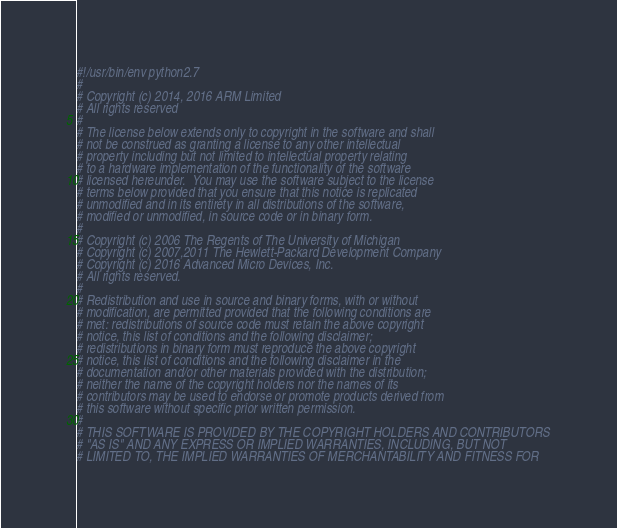Convert code to text. <code><loc_0><loc_0><loc_500><loc_500><_Python_>#!/usr/bin/env python2.7
#
# Copyright (c) 2014, 2016 ARM Limited
# All rights reserved
#
# The license below extends only to copyright in the software and shall
# not be construed as granting a license to any other intellectual
# property including but not limited to intellectual property relating
# to a hardware implementation of the functionality of the software
# licensed hereunder.  You may use the software subject to the license
# terms below provided that you ensure that this notice is replicated
# unmodified and in its entirety in all distributions of the software,
# modified or unmodified, in source code or in binary form.
#
# Copyright (c) 2006 The Regents of The University of Michigan
# Copyright (c) 2007,2011 The Hewlett-Packard Development Company
# Copyright (c) 2016 Advanced Micro Devices, Inc.
# All rights reserved.
#
# Redistribution and use in source and binary forms, with or without
# modification, are permitted provided that the following conditions are
# met: redistributions of source code must retain the above copyright
# notice, this list of conditions and the following disclaimer;
# redistributions in binary form must reproduce the above copyright
# notice, this list of conditions and the following disclaimer in the
# documentation and/or other materials provided with the distribution;
# neither the name of the copyright holders nor the names of its
# contributors may be used to endorse or promote products derived from
# this software without specific prior written permission.
#
# THIS SOFTWARE IS PROVIDED BY THE COPYRIGHT HOLDERS AND CONTRIBUTORS
# "AS IS" AND ANY EXPRESS OR IMPLIED WARRANTIES, INCLUDING, BUT NOT
# LIMITED TO, THE IMPLIED WARRANTIES OF MERCHANTABILITY AND FITNESS FOR</code> 